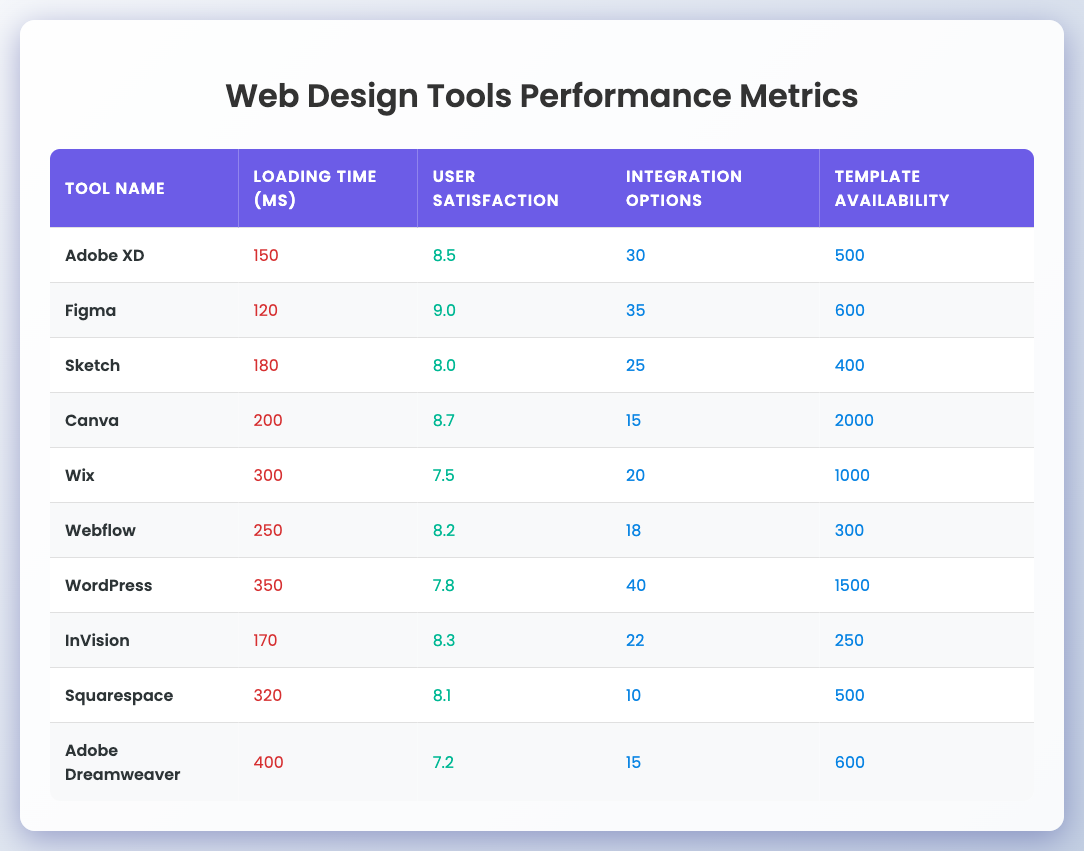What is the loading time of Canva? The table shows a specific row for Canva with a corresponding loading time of 200 milliseconds.
Answer: 200 ms Which tool has the highest user satisfaction score? By comparing the user satisfaction scores, Figma has the highest score of 9.0 among all tools listed.
Answer: Figma How many integration options does WordPress offer? The data for WordPress indicates that it has 40 integration options, as seen in its respective row.
Answer: 40 What is the average loading time of the tools listed? To calculate the average, sum the loading times: (150 + 120 + 180 + 200 + 300 + 250 + 350 + 170 + 320 + 400) = 2240 ms. There are 10 tools, so the average loading time is 2240 / 10 = 224 ms.
Answer: 224 ms Is Canva the tool with the most template availability? Upon reviewing the template availability, Canva has 2000 templates, which is higher than the counts for all other tools in the table.
Answer: Yes Which tool has a lower user satisfaction score: Wix or WordPress? Wix has a user satisfaction score of 7.5, while WordPress has a score of 7.8. Since 7.5 is lower than 7.8, Wix has the lower score.
Answer: Wix What is the difference in loading time between Figma and Adobe Dreamweaver? The loading time for Figma is 120 ms and for Adobe Dreamweaver is 400 ms. The difference is 400 - 120 = 280 ms.
Answer: 280 ms What is the total number of integration options for Adobe XD and InVision? Adobe XD offers 30 integration options and InVision offers 22. Adding these gives: 30 + 22 = 52 integration options.
Answer: 52 Which tool has the lowest user satisfaction score? By examining the scores, Adobe Dreamweaver has the lowest score of 7.2, as listed in its row.
Answer: Adobe Dreamweaver Compare the template availability between Sketch and Squarespace; which one has more? Sketch has 400 templates while Squarespace has 500 templates. Since 500 is greater than 400, Squarespace has more templates than Sketch.
Answer: Squarespace 